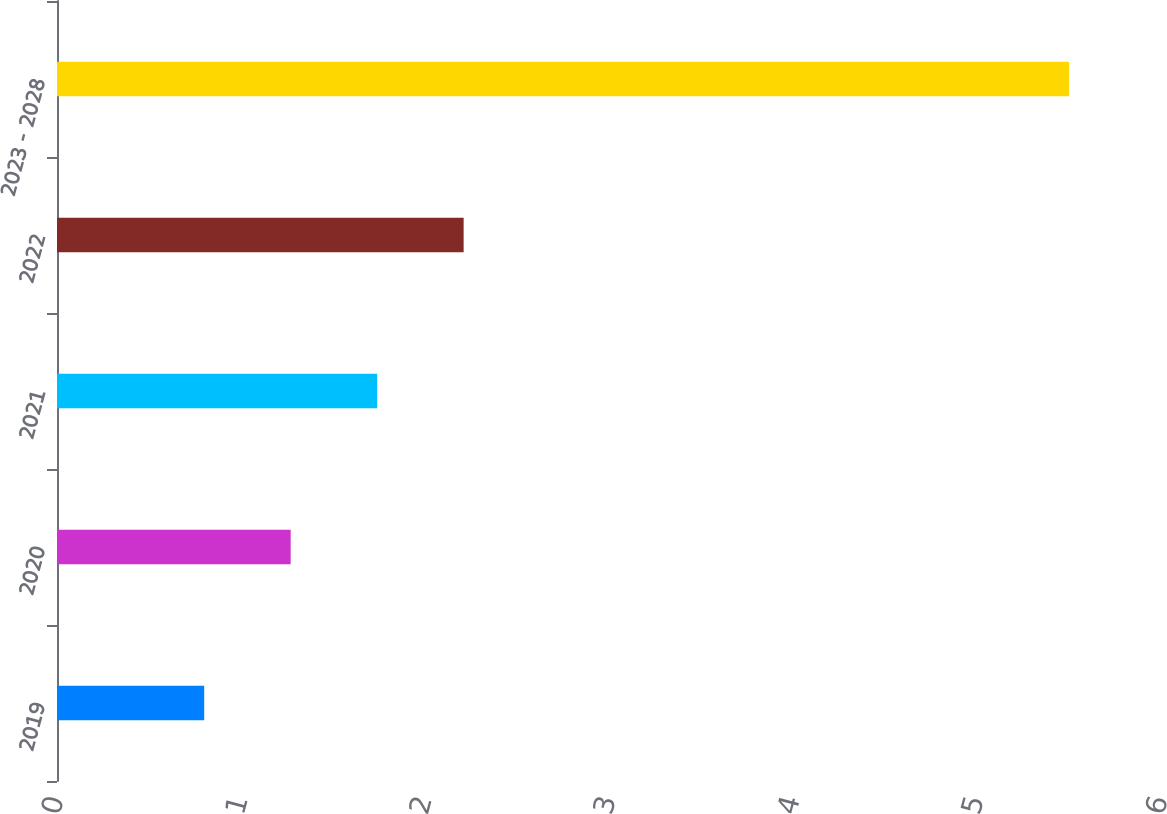Convert chart. <chart><loc_0><loc_0><loc_500><loc_500><bar_chart><fcel>2019<fcel>2020<fcel>2021<fcel>2022<fcel>2023 - 2028<nl><fcel>0.8<fcel>1.27<fcel>1.74<fcel>2.21<fcel>5.5<nl></chart> 